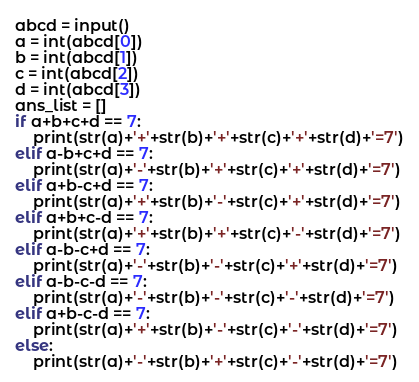Convert code to text. <code><loc_0><loc_0><loc_500><loc_500><_Python_>abcd = input()
a = int(abcd[0])
b = int(abcd[1])
c = int(abcd[2])
d = int(abcd[3])
ans_list = []
if a+b+c+d == 7:
    print(str(a)+'+'+str(b)+'+'+str(c)+'+'+str(d)+'=7')
elif a-b+c+d == 7:
    print(str(a)+'-'+str(b)+'+'+str(c)+'+'+str(d)+'=7')
elif a+b-c+d == 7:
    print(str(a)+'+'+str(b)+'-'+str(c)+'+'+str(d)+'=7')
elif a+b+c-d == 7:
    print(str(a)+'+'+str(b)+'+'+str(c)+'-'+str(d)+'=7')
elif a-b-c+d == 7:
    print(str(a)+'-'+str(b)+'-'+str(c)+'+'+str(d)+'=7')
elif a-b-c-d == 7:
    print(str(a)+'-'+str(b)+'-'+str(c)+'-'+str(d)+'=7')
elif a+b-c-d == 7:
    print(str(a)+'+'+str(b)+'-'+str(c)+'-'+str(d)+'=7')
else:
    print(str(a)+'-'+str(b)+'+'+str(c)+'-'+str(d)+'=7')</code> 